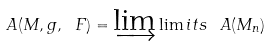<formula> <loc_0><loc_0><loc_500><loc_500>\ A ( M , g , \ F ) = \varinjlim \lim i t s \, \ A ( M _ { n } )</formula> 